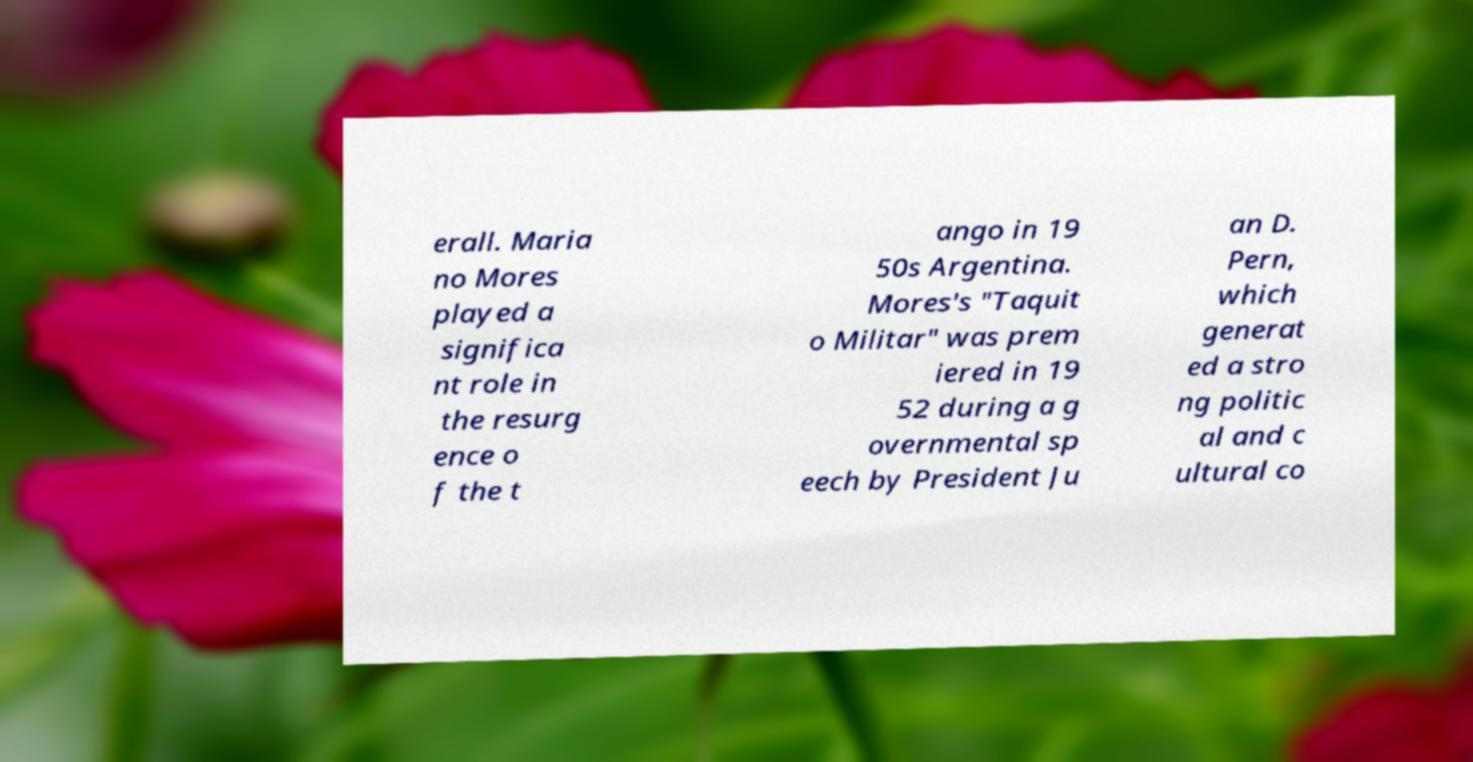Please identify and transcribe the text found in this image. erall. Maria no Mores played a significa nt role in the resurg ence o f the t ango in 19 50s Argentina. Mores's "Taquit o Militar" was prem iered in 19 52 during a g overnmental sp eech by President Ju an D. Pern, which generat ed a stro ng politic al and c ultural co 